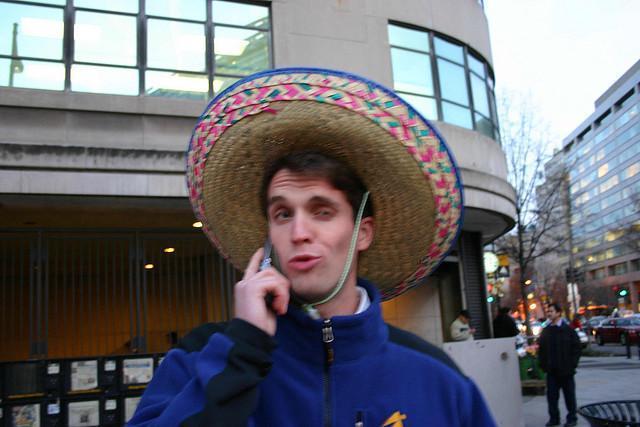How many people are there?
Give a very brief answer. 2. How many horses are shown?
Give a very brief answer. 0. 